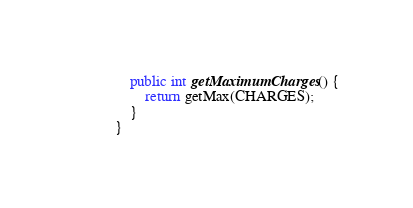Convert code to text. <code><loc_0><loc_0><loc_500><loc_500><_Java_>    public int getMaximumCharges() {
        return getMax(CHARGES);
    }
}
</code> 